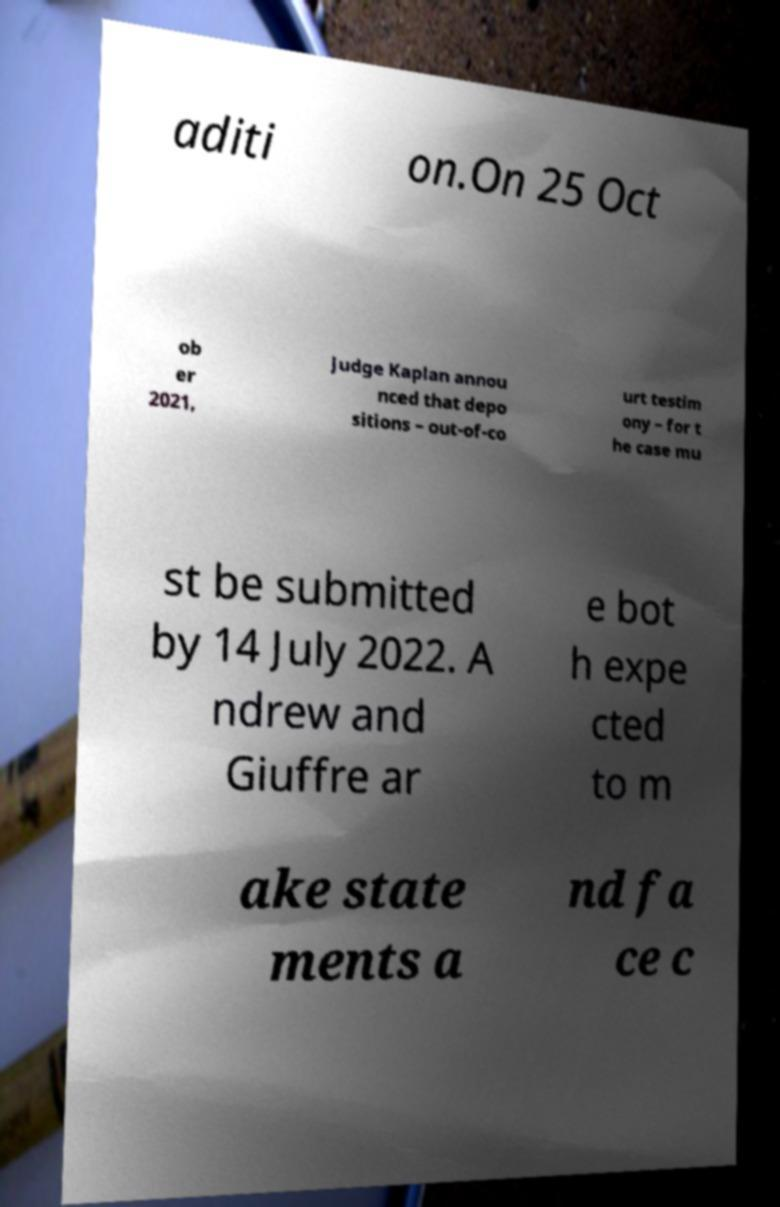Please identify and transcribe the text found in this image. aditi on.On 25 Oct ob er 2021, Judge Kaplan annou nced that depo sitions – out-of-co urt testim ony – for t he case mu st be submitted by 14 July 2022. A ndrew and Giuffre ar e bot h expe cted to m ake state ments a nd fa ce c 